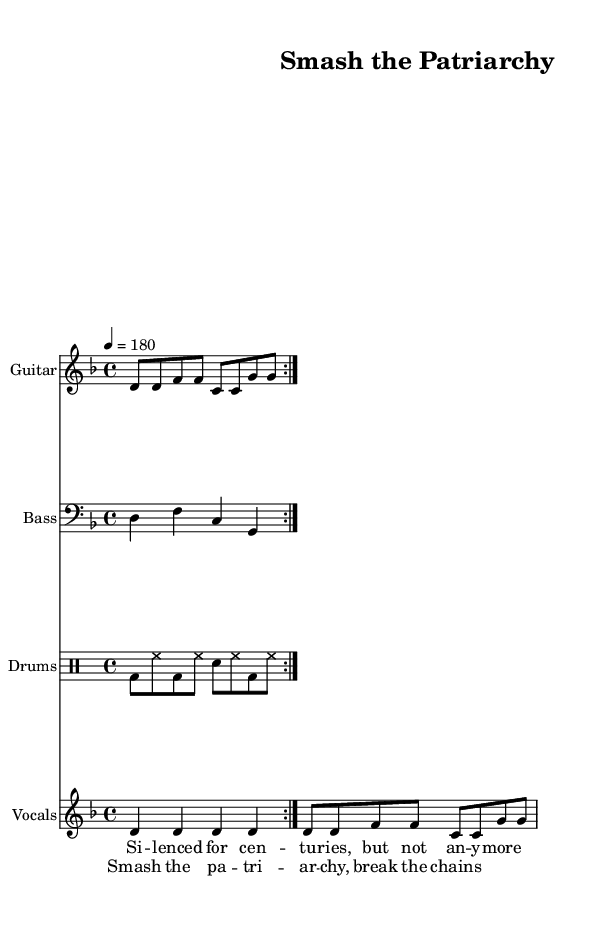What is the title of this piece? The title is indicated in the header section of the sheet music, which states "Smash the Patriarchy".
Answer: Smash the Patriarchy What is the time signature of the music? The time signature is located after the key signature and indicates how many beats are in each measure; here, it is shown as 4/4.
Answer: 4/4 What is the key signature of this music? The key signature is placed at the beginning, showing D minor, which has one flat.
Answer: D minor What is the tempo marking of the piece? The tempo is indicated with a quarter note equals 180, meaning the piece should be played at a fast pace of 180 beats per minute.
Answer: 180 How many times is the guitar riff repeated? The text indicates that the guitar riff has a repeat volta notation, which specifies that it should be played twice.
Answer: 2 What do the lyrics of the chorus express? The lyrics in the chorus are "Smash the patriarchy, break the chains," suggesting a strong message against societal oppression, consistent with feminist themes.
Answer: Smash the patriarchy, break the chains 